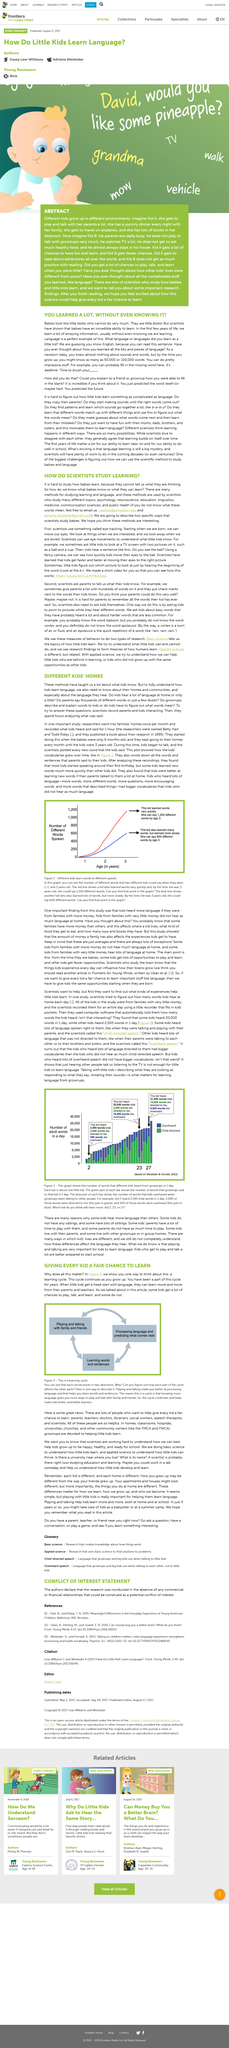Identify some key points in this picture. Babies have an incredible ability to learn, and it is truly remarkable to watch them grow and develop new skills. The article discusses the methods used by scientists to investigate the process of learning. Scientists spent hours analyzing the recorded interactions between parents and children in order to gain insight into the nature of their interactions. The number of words an adult might know can vary greatly, ranging from 50,000 to 100,000. Scientists study a wide range of topics, including psychology, neuroscience, education, linguistics, medicine, communication sciences, and public health. 